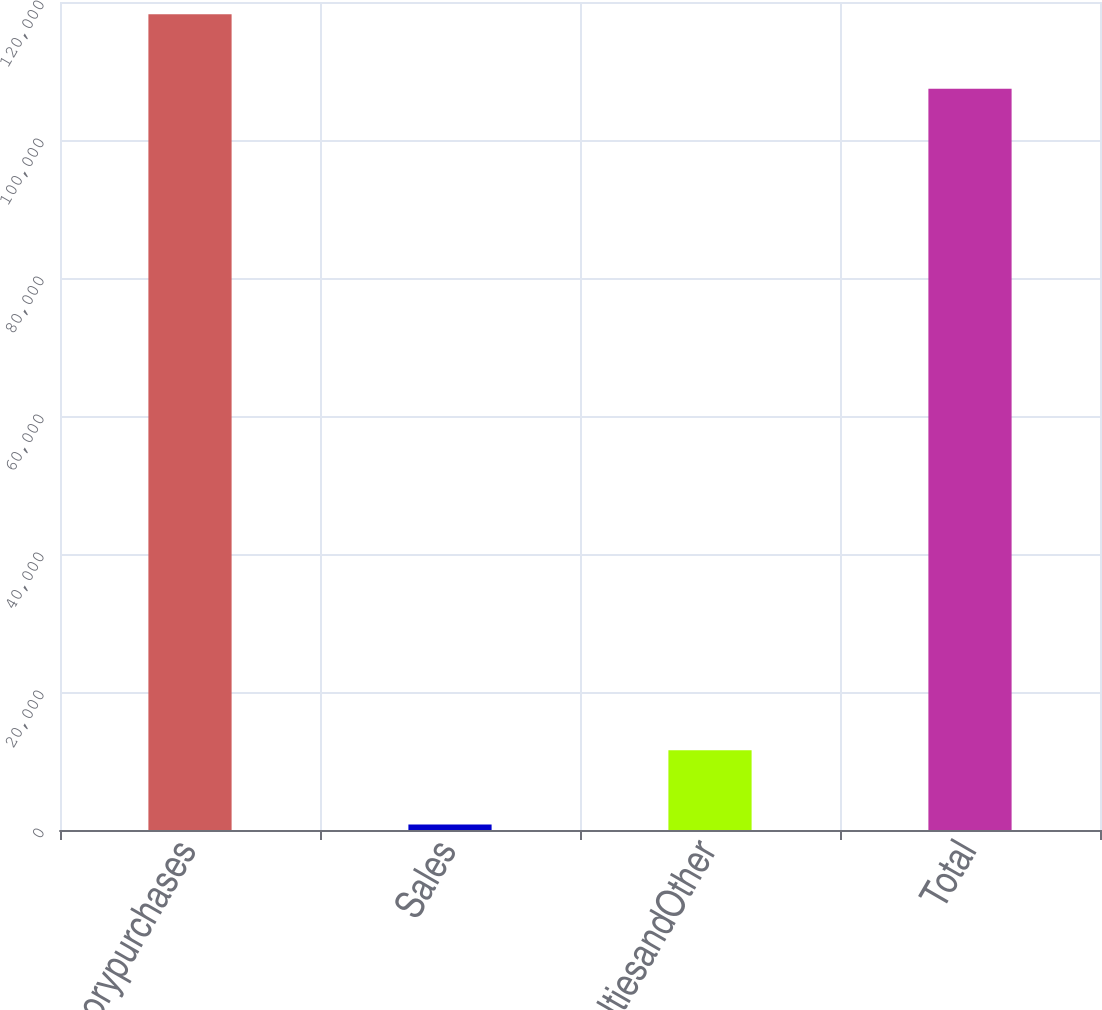<chart> <loc_0><loc_0><loc_500><loc_500><bar_chart><fcel>Inventorypurchases<fcel>Sales<fcel>RoyaltiesandOther<fcel>Total<nl><fcel>118210<fcel>803<fcel>11574.8<fcel>107438<nl></chart> 